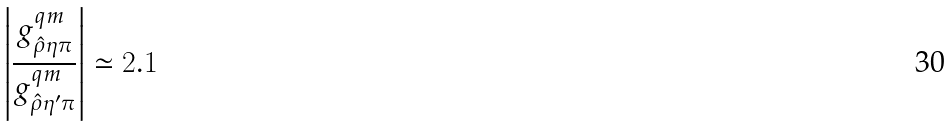<formula> <loc_0><loc_0><loc_500><loc_500>\left | { \frac { g _ { \hat { \rho } \eta \pi } ^ { q m } } { g _ { \hat { \rho } \eta ^ { \prime } \pi } ^ { q m } } } \right | \simeq 2 . 1</formula> 